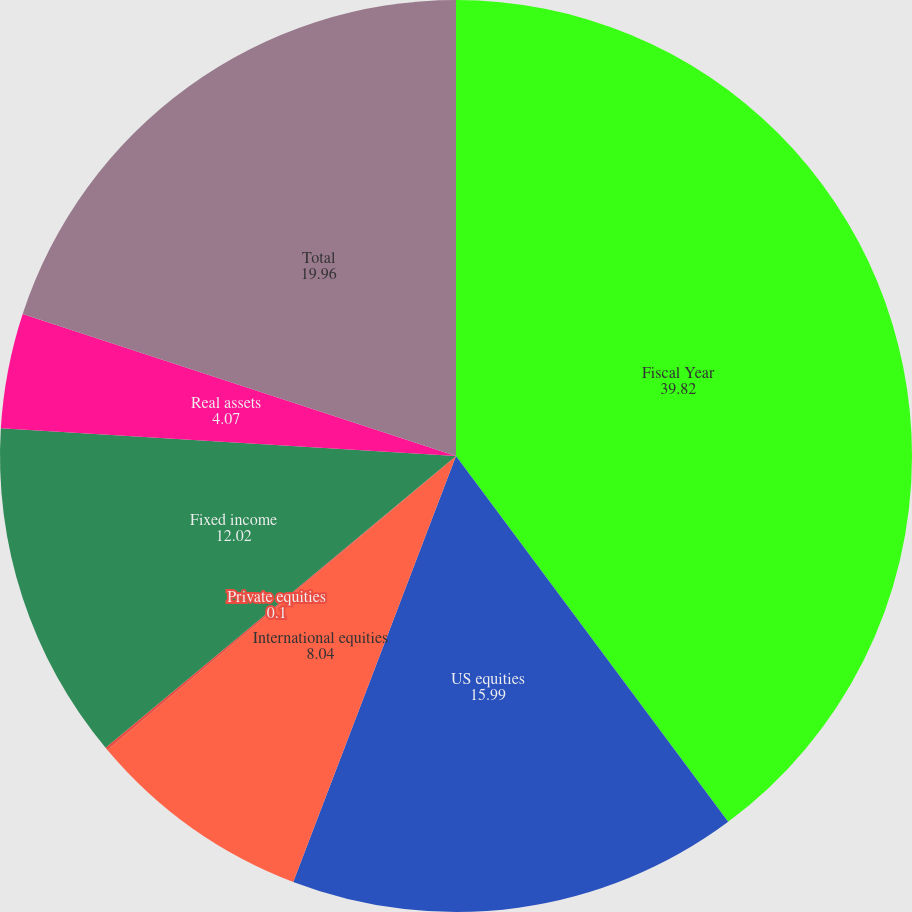<chart> <loc_0><loc_0><loc_500><loc_500><pie_chart><fcel>Fiscal Year<fcel>US equities<fcel>International equities<fcel>Private equities<fcel>Fixed income<fcel>Real assets<fcel>Total<nl><fcel>39.82%<fcel>15.99%<fcel>8.04%<fcel>0.1%<fcel>12.02%<fcel>4.07%<fcel>19.96%<nl></chart> 